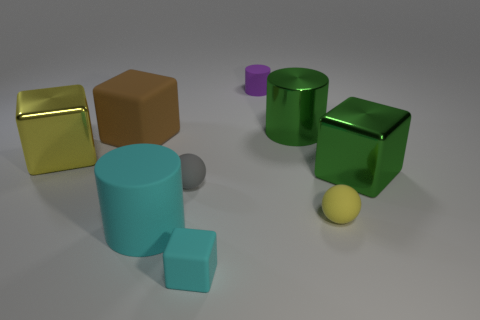There is a big object that is in front of the green cylinder and on the right side of the tiny gray ball; what is its shape?
Give a very brief answer. Cube. How many things are large rubber things that are in front of the yellow sphere or tiny things right of the small cylinder?
Provide a succinct answer. 2. What number of other things are there of the same size as the yellow shiny thing?
Make the answer very short. 4. Is the color of the metal block to the left of the cyan rubber cylinder the same as the large metal cylinder?
Your answer should be compact. No. How big is the object that is both behind the big brown matte thing and in front of the tiny purple object?
Keep it short and to the point. Large. What number of small objects are purple matte cylinders or blue metal things?
Make the answer very short. 1. There is a green thing on the left side of the tiny yellow rubber ball; what is its shape?
Provide a short and direct response. Cylinder. How many cyan rubber cylinders are there?
Provide a succinct answer. 1. Do the tiny cylinder and the small cyan thing have the same material?
Give a very brief answer. Yes. Is the number of shiny blocks that are to the right of the big brown rubber object greater than the number of red matte cylinders?
Your answer should be compact. Yes. 